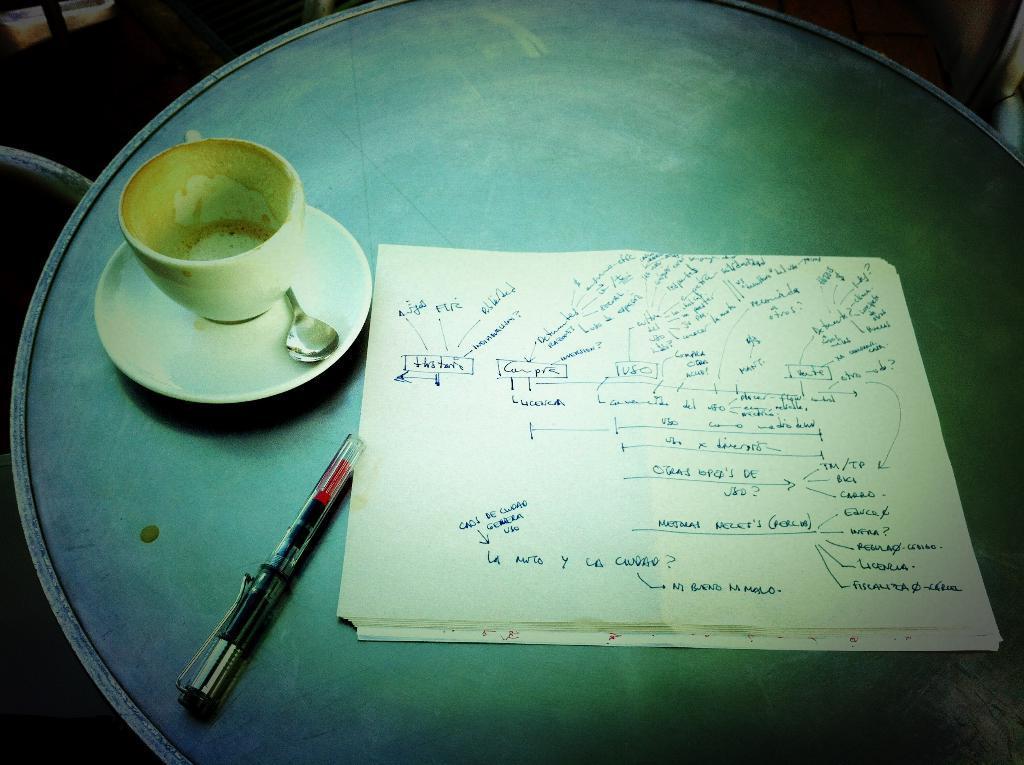How would you summarize this image in a sentence or two? In this image we can see a paper with some written text on it, a pen and a cup with saucer and a spoon which are placed on the table. 